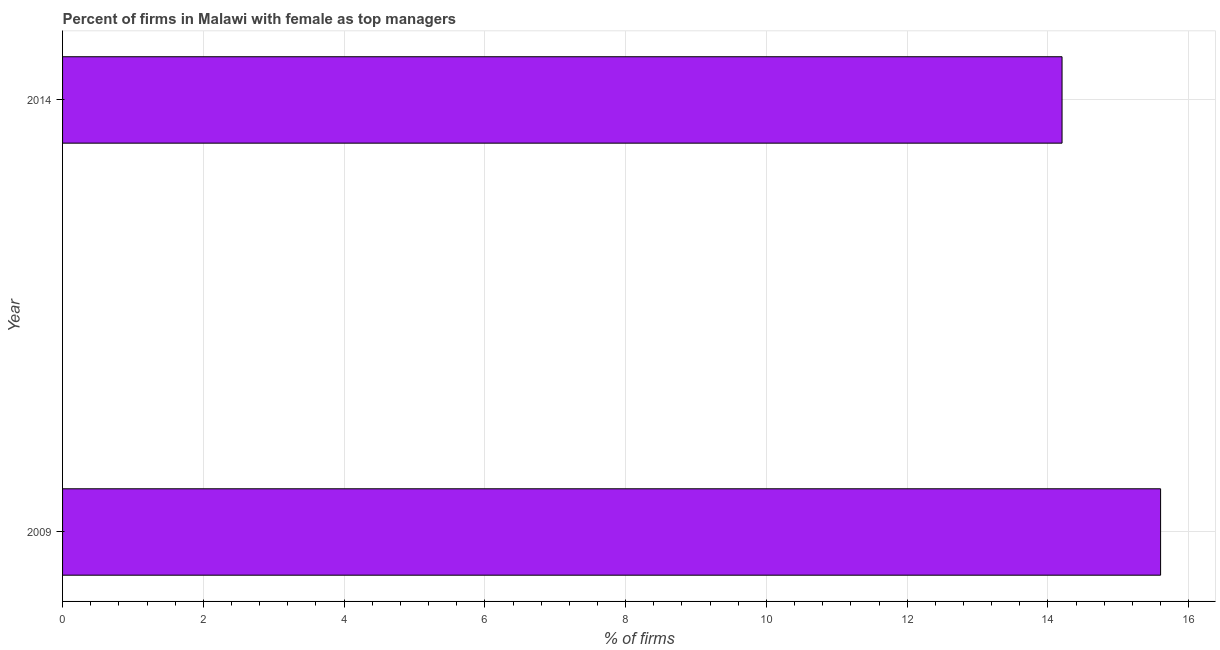Does the graph contain grids?
Your answer should be very brief. Yes. What is the title of the graph?
Your response must be concise. Percent of firms in Malawi with female as top managers. What is the label or title of the X-axis?
Provide a short and direct response. % of firms. What is the label or title of the Y-axis?
Your response must be concise. Year. What is the percentage of firms with female as top manager in 2009?
Provide a short and direct response. 15.6. Across all years, what is the maximum percentage of firms with female as top manager?
Ensure brevity in your answer.  15.6. Across all years, what is the minimum percentage of firms with female as top manager?
Give a very brief answer. 14.2. In which year was the percentage of firms with female as top manager minimum?
Ensure brevity in your answer.  2014. What is the sum of the percentage of firms with female as top manager?
Provide a succinct answer. 29.8. What is the difference between the percentage of firms with female as top manager in 2009 and 2014?
Offer a very short reply. 1.4. What is the median percentage of firms with female as top manager?
Offer a very short reply. 14.9. What is the ratio of the percentage of firms with female as top manager in 2009 to that in 2014?
Your response must be concise. 1.1. How many bars are there?
Ensure brevity in your answer.  2. How many years are there in the graph?
Your answer should be very brief. 2. What is the difference between two consecutive major ticks on the X-axis?
Offer a very short reply. 2. Are the values on the major ticks of X-axis written in scientific E-notation?
Provide a short and direct response. No. What is the % of firms of 2014?
Your answer should be very brief. 14.2. What is the ratio of the % of firms in 2009 to that in 2014?
Keep it short and to the point. 1.1. 